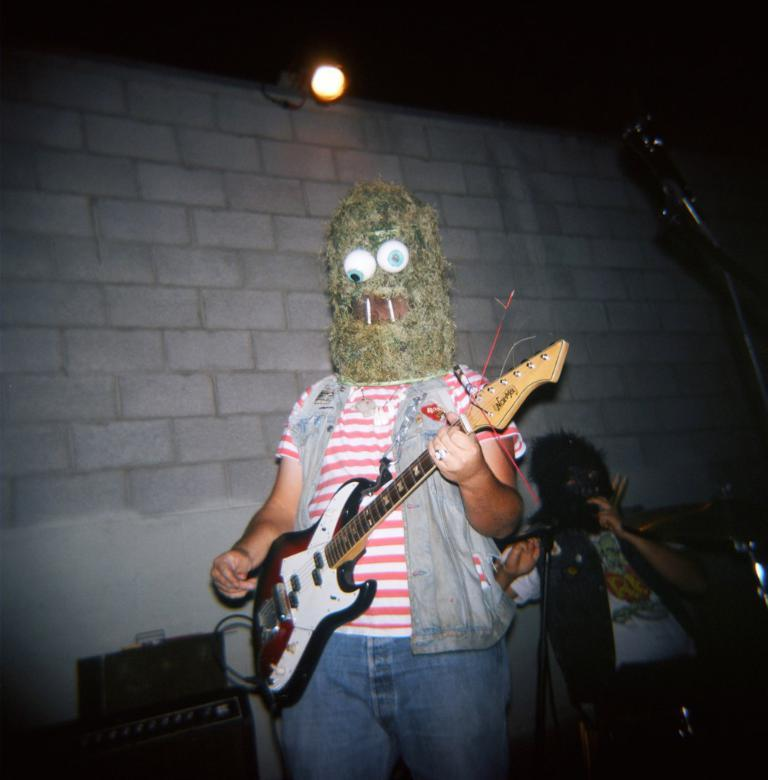What is the person in the image doing? The person is standing in the image and holding a guitar. Can you describe the person's attire? The person is wearing a mask. Is there anyone else visible in the image? Yes, there is another person visible in the background. What can be seen in the background of the image? There is a light in the background. Can you tell me how many houses are visible in the image? There is no house present in the image. What type of lake can be seen in the background of the image? There is no lake present in the image. 